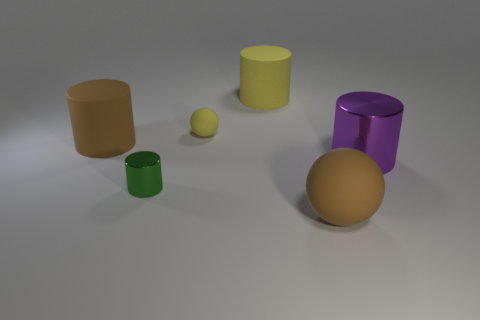Add 1 tiny things. How many objects exist? 7 Subtract all yellow cylinders. How many cylinders are left? 3 Subtract all purple cylinders. How many cylinders are left? 3 Subtract all balls. How many objects are left? 4 Subtract 2 spheres. How many spheres are left? 0 Subtract all red spheres. Subtract all cyan cubes. How many spheres are left? 2 Subtract all purple cylinders. How many yellow spheres are left? 1 Subtract all cyan blocks. Subtract all yellow cylinders. How many objects are left? 5 Add 1 small yellow matte spheres. How many small yellow matte spheres are left? 2 Add 2 large yellow metal spheres. How many large yellow metal spheres exist? 2 